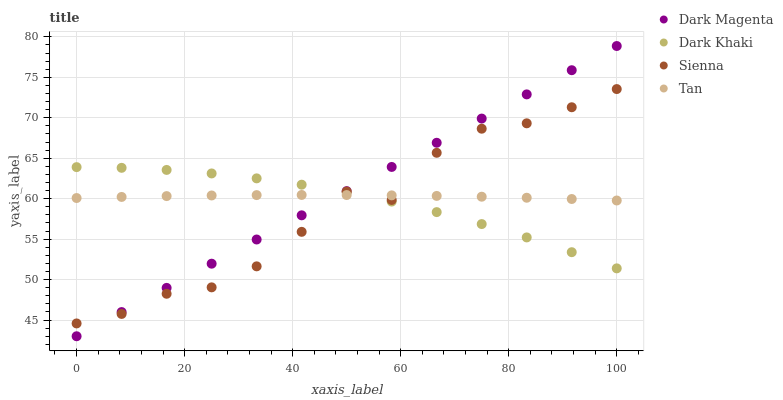Does Sienna have the minimum area under the curve?
Answer yes or no. Yes. Does Dark Magenta have the maximum area under the curve?
Answer yes or no. Yes. Does Tan have the minimum area under the curve?
Answer yes or no. No. Does Tan have the maximum area under the curve?
Answer yes or no. No. Is Dark Magenta the smoothest?
Answer yes or no. Yes. Is Sienna the roughest?
Answer yes or no. Yes. Is Tan the smoothest?
Answer yes or no. No. Is Tan the roughest?
Answer yes or no. No. Does Dark Magenta have the lowest value?
Answer yes or no. Yes. Does Sienna have the lowest value?
Answer yes or no. No. Does Dark Magenta have the highest value?
Answer yes or no. Yes. Does Sienna have the highest value?
Answer yes or no. No. Does Sienna intersect Dark Magenta?
Answer yes or no. Yes. Is Sienna less than Dark Magenta?
Answer yes or no. No. Is Sienna greater than Dark Magenta?
Answer yes or no. No. 